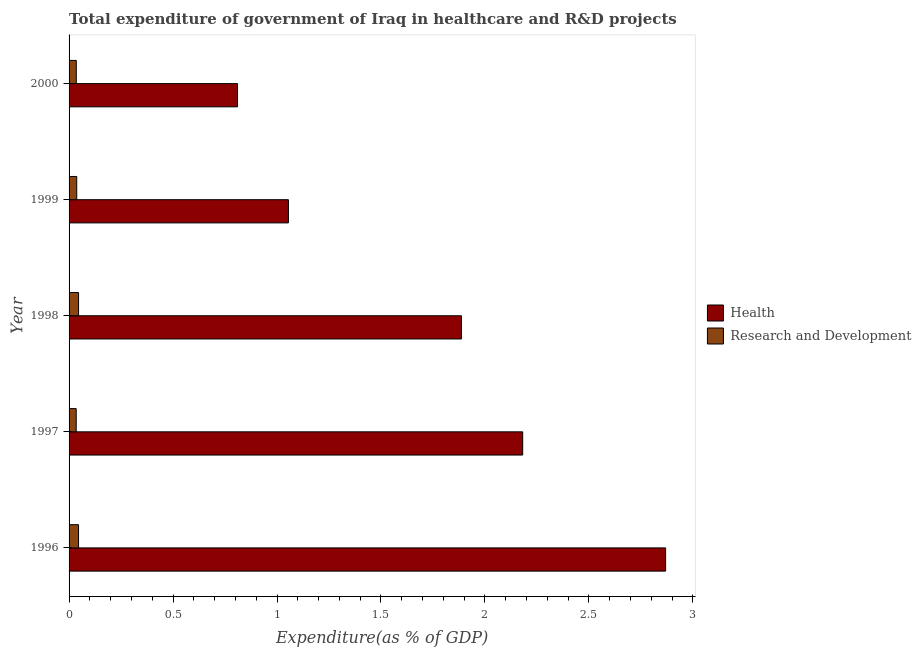How many different coloured bars are there?
Offer a very short reply. 2. How many groups of bars are there?
Provide a succinct answer. 5. How many bars are there on the 5th tick from the top?
Keep it short and to the point. 2. How many bars are there on the 4th tick from the bottom?
Your response must be concise. 2. What is the label of the 3rd group of bars from the top?
Offer a terse response. 1998. In how many cases, is the number of bars for a given year not equal to the number of legend labels?
Your response must be concise. 0. What is the expenditure in r&d in 1998?
Make the answer very short. 0.05. Across all years, what is the maximum expenditure in r&d?
Provide a short and direct response. 0.05. Across all years, what is the minimum expenditure in r&d?
Your answer should be very brief. 0.03. In which year was the expenditure in healthcare minimum?
Give a very brief answer. 2000. What is the total expenditure in r&d in the graph?
Offer a terse response. 0.2. What is the difference between the expenditure in healthcare in 1996 and that in 2000?
Your response must be concise. 2.06. What is the difference between the expenditure in r&d in 1998 and the expenditure in healthcare in 1996?
Ensure brevity in your answer.  -2.82. What is the average expenditure in r&d per year?
Provide a succinct answer. 0.04. In the year 1998, what is the difference between the expenditure in r&d and expenditure in healthcare?
Ensure brevity in your answer.  -1.84. What is the ratio of the expenditure in healthcare in 1997 to that in 2000?
Make the answer very short. 2.69. Is the expenditure in r&d in 1996 less than that in 2000?
Provide a succinct answer. No. What is the difference between the highest and the second highest expenditure in healthcare?
Your answer should be very brief. 0.69. What is the difference between the highest and the lowest expenditure in healthcare?
Your answer should be very brief. 2.06. In how many years, is the expenditure in r&d greater than the average expenditure in r&d taken over all years?
Give a very brief answer. 2. Is the sum of the expenditure in r&d in 1997 and 1999 greater than the maximum expenditure in healthcare across all years?
Your answer should be compact. No. What does the 2nd bar from the top in 1999 represents?
Ensure brevity in your answer.  Health. What does the 1st bar from the bottom in 1997 represents?
Offer a terse response. Health. Are all the bars in the graph horizontal?
Keep it short and to the point. Yes. How many years are there in the graph?
Your answer should be compact. 5. What is the difference between two consecutive major ticks on the X-axis?
Offer a very short reply. 0.5. Does the graph contain grids?
Keep it short and to the point. No. Where does the legend appear in the graph?
Make the answer very short. Center right. How are the legend labels stacked?
Ensure brevity in your answer.  Vertical. What is the title of the graph?
Ensure brevity in your answer.  Total expenditure of government of Iraq in healthcare and R&D projects. What is the label or title of the X-axis?
Ensure brevity in your answer.  Expenditure(as % of GDP). What is the Expenditure(as % of GDP) of Health in 1996?
Ensure brevity in your answer.  2.87. What is the Expenditure(as % of GDP) in Research and Development in 1996?
Offer a very short reply. 0.05. What is the Expenditure(as % of GDP) in Health in 1997?
Offer a terse response. 2.18. What is the Expenditure(as % of GDP) of Research and Development in 1997?
Your answer should be compact. 0.03. What is the Expenditure(as % of GDP) in Health in 1998?
Provide a succinct answer. 1.89. What is the Expenditure(as % of GDP) of Research and Development in 1998?
Make the answer very short. 0.05. What is the Expenditure(as % of GDP) of Health in 1999?
Your response must be concise. 1.05. What is the Expenditure(as % of GDP) in Research and Development in 1999?
Give a very brief answer. 0.04. What is the Expenditure(as % of GDP) in Health in 2000?
Make the answer very short. 0.81. What is the Expenditure(as % of GDP) of Research and Development in 2000?
Give a very brief answer. 0.03. Across all years, what is the maximum Expenditure(as % of GDP) in Health?
Your response must be concise. 2.87. Across all years, what is the maximum Expenditure(as % of GDP) of Research and Development?
Keep it short and to the point. 0.05. Across all years, what is the minimum Expenditure(as % of GDP) in Health?
Offer a terse response. 0.81. Across all years, what is the minimum Expenditure(as % of GDP) in Research and Development?
Offer a terse response. 0.03. What is the total Expenditure(as % of GDP) of Health in the graph?
Offer a terse response. 8.8. What is the total Expenditure(as % of GDP) in Research and Development in the graph?
Offer a very short reply. 0.2. What is the difference between the Expenditure(as % of GDP) in Health in 1996 and that in 1997?
Provide a short and direct response. 0.69. What is the difference between the Expenditure(as % of GDP) in Research and Development in 1996 and that in 1997?
Keep it short and to the point. 0.01. What is the difference between the Expenditure(as % of GDP) in Health in 1996 and that in 1998?
Give a very brief answer. 0.98. What is the difference between the Expenditure(as % of GDP) of Research and Development in 1996 and that in 1998?
Make the answer very short. -0. What is the difference between the Expenditure(as % of GDP) of Health in 1996 and that in 1999?
Provide a succinct answer. 1.81. What is the difference between the Expenditure(as % of GDP) in Research and Development in 1996 and that in 1999?
Provide a short and direct response. 0.01. What is the difference between the Expenditure(as % of GDP) in Health in 1996 and that in 2000?
Make the answer very short. 2.06. What is the difference between the Expenditure(as % of GDP) of Research and Development in 1996 and that in 2000?
Ensure brevity in your answer.  0.01. What is the difference between the Expenditure(as % of GDP) of Health in 1997 and that in 1998?
Make the answer very short. 0.29. What is the difference between the Expenditure(as % of GDP) of Research and Development in 1997 and that in 1998?
Your response must be concise. -0.01. What is the difference between the Expenditure(as % of GDP) in Health in 1997 and that in 1999?
Give a very brief answer. 1.13. What is the difference between the Expenditure(as % of GDP) of Research and Development in 1997 and that in 1999?
Offer a very short reply. -0. What is the difference between the Expenditure(as % of GDP) in Health in 1997 and that in 2000?
Make the answer very short. 1.37. What is the difference between the Expenditure(as % of GDP) of Research and Development in 1997 and that in 2000?
Give a very brief answer. -0. What is the difference between the Expenditure(as % of GDP) in Health in 1998 and that in 1999?
Make the answer very short. 0.83. What is the difference between the Expenditure(as % of GDP) of Research and Development in 1998 and that in 1999?
Make the answer very short. 0.01. What is the difference between the Expenditure(as % of GDP) in Health in 1998 and that in 2000?
Your answer should be compact. 1.08. What is the difference between the Expenditure(as % of GDP) of Research and Development in 1998 and that in 2000?
Provide a short and direct response. 0.01. What is the difference between the Expenditure(as % of GDP) in Health in 1999 and that in 2000?
Ensure brevity in your answer.  0.24. What is the difference between the Expenditure(as % of GDP) in Research and Development in 1999 and that in 2000?
Provide a short and direct response. 0. What is the difference between the Expenditure(as % of GDP) in Health in 1996 and the Expenditure(as % of GDP) in Research and Development in 1997?
Keep it short and to the point. 2.83. What is the difference between the Expenditure(as % of GDP) of Health in 1996 and the Expenditure(as % of GDP) of Research and Development in 1998?
Provide a succinct answer. 2.82. What is the difference between the Expenditure(as % of GDP) of Health in 1996 and the Expenditure(as % of GDP) of Research and Development in 1999?
Your answer should be compact. 2.83. What is the difference between the Expenditure(as % of GDP) of Health in 1996 and the Expenditure(as % of GDP) of Research and Development in 2000?
Provide a short and direct response. 2.83. What is the difference between the Expenditure(as % of GDP) of Health in 1997 and the Expenditure(as % of GDP) of Research and Development in 1998?
Offer a very short reply. 2.14. What is the difference between the Expenditure(as % of GDP) of Health in 1997 and the Expenditure(as % of GDP) of Research and Development in 1999?
Provide a succinct answer. 2.14. What is the difference between the Expenditure(as % of GDP) in Health in 1997 and the Expenditure(as % of GDP) in Research and Development in 2000?
Provide a short and direct response. 2.15. What is the difference between the Expenditure(as % of GDP) in Health in 1998 and the Expenditure(as % of GDP) in Research and Development in 1999?
Give a very brief answer. 1.85. What is the difference between the Expenditure(as % of GDP) of Health in 1998 and the Expenditure(as % of GDP) of Research and Development in 2000?
Ensure brevity in your answer.  1.85. What is the difference between the Expenditure(as % of GDP) of Health in 1999 and the Expenditure(as % of GDP) of Research and Development in 2000?
Keep it short and to the point. 1.02. What is the average Expenditure(as % of GDP) of Health per year?
Your answer should be compact. 1.76. What is the average Expenditure(as % of GDP) in Research and Development per year?
Your answer should be very brief. 0.04. In the year 1996, what is the difference between the Expenditure(as % of GDP) of Health and Expenditure(as % of GDP) of Research and Development?
Your answer should be compact. 2.82. In the year 1997, what is the difference between the Expenditure(as % of GDP) of Health and Expenditure(as % of GDP) of Research and Development?
Keep it short and to the point. 2.15. In the year 1998, what is the difference between the Expenditure(as % of GDP) in Health and Expenditure(as % of GDP) in Research and Development?
Provide a succinct answer. 1.84. In the year 1999, what is the difference between the Expenditure(as % of GDP) of Health and Expenditure(as % of GDP) of Research and Development?
Ensure brevity in your answer.  1.02. In the year 2000, what is the difference between the Expenditure(as % of GDP) of Health and Expenditure(as % of GDP) of Research and Development?
Your answer should be compact. 0.78. What is the ratio of the Expenditure(as % of GDP) in Health in 1996 to that in 1997?
Provide a succinct answer. 1.31. What is the ratio of the Expenditure(as % of GDP) in Research and Development in 1996 to that in 1997?
Offer a terse response. 1.33. What is the ratio of the Expenditure(as % of GDP) in Health in 1996 to that in 1998?
Keep it short and to the point. 1.52. What is the ratio of the Expenditure(as % of GDP) in Health in 1996 to that in 1999?
Your answer should be very brief. 2.72. What is the ratio of the Expenditure(as % of GDP) in Research and Development in 1996 to that in 1999?
Provide a succinct answer. 1.24. What is the ratio of the Expenditure(as % of GDP) of Health in 1996 to that in 2000?
Give a very brief answer. 3.54. What is the ratio of the Expenditure(as % of GDP) of Research and Development in 1996 to that in 2000?
Provide a succinct answer. 1.31. What is the ratio of the Expenditure(as % of GDP) of Health in 1997 to that in 1998?
Offer a very short reply. 1.16. What is the ratio of the Expenditure(as % of GDP) in Research and Development in 1997 to that in 1998?
Offer a very short reply. 0.75. What is the ratio of the Expenditure(as % of GDP) in Health in 1997 to that in 1999?
Provide a short and direct response. 2.07. What is the ratio of the Expenditure(as % of GDP) of Research and Development in 1997 to that in 1999?
Your answer should be very brief. 0.93. What is the ratio of the Expenditure(as % of GDP) of Health in 1997 to that in 2000?
Your response must be concise. 2.69. What is the ratio of the Expenditure(as % of GDP) in Health in 1998 to that in 1999?
Provide a succinct answer. 1.79. What is the ratio of the Expenditure(as % of GDP) of Research and Development in 1998 to that in 1999?
Your answer should be very brief. 1.24. What is the ratio of the Expenditure(as % of GDP) of Health in 1998 to that in 2000?
Your answer should be very brief. 2.33. What is the ratio of the Expenditure(as % of GDP) of Research and Development in 1998 to that in 2000?
Your response must be concise. 1.31. What is the ratio of the Expenditure(as % of GDP) of Health in 1999 to that in 2000?
Your response must be concise. 1.3. What is the ratio of the Expenditure(as % of GDP) of Research and Development in 1999 to that in 2000?
Your response must be concise. 1.06. What is the difference between the highest and the second highest Expenditure(as % of GDP) in Health?
Provide a succinct answer. 0.69. What is the difference between the highest and the lowest Expenditure(as % of GDP) in Health?
Your answer should be very brief. 2.06. What is the difference between the highest and the lowest Expenditure(as % of GDP) in Research and Development?
Give a very brief answer. 0.01. 